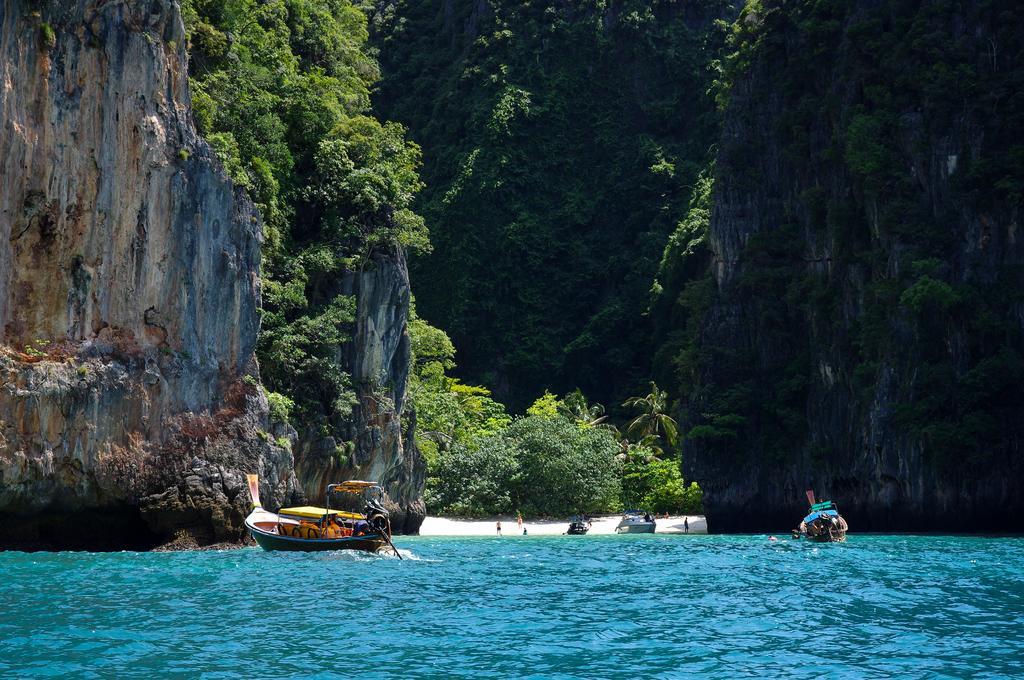Describe this image in one or two sentences. There are two boats in the river and there are mountains which has trees on it. 